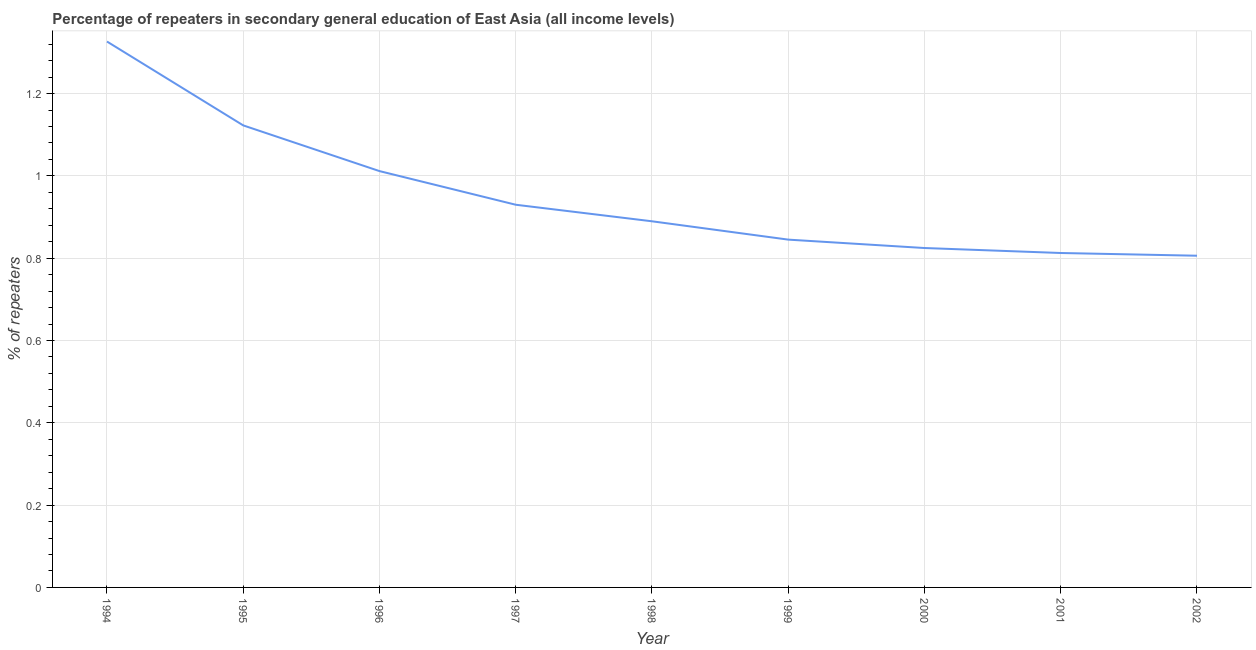What is the percentage of repeaters in 1998?
Provide a short and direct response. 0.89. Across all years, what is the maximum percentage of repeaters?
Provide a short and direct response. 1.33. Across all years, what is the minimum percentage of repeaters?
Make the answer very short. 0.81. In which year was the percentage of repeaters minimum?
Keep it short and to the point. 2002. What is the sum of the percentage of repeaters?
Provide a succinct answer. 8.57. What is the difference between the percentage of repeaters in 2001 and 2002?
Give a very brief answer. 0.01. What is the average percentage of repeaters per year?
Your answer should be compact. 0.95. What is the median percentage of repeaters?
Provide a succinct answer. 0.89. In how many years, is the percentage of repeaters greater than 0.12 %?
Provide a short and direct response. 9. Do a majority of the years between 1995 and 1997 (inclusive) have percentage of repeaters greater than 0.08 %?
Provide a succinct answer. Yes. What is the ratio of the percentage of repeaters in 1997 to that in 2000?
Your answer should be very brief. 1.13. Is the percentage of repeaters in 1994 less than that in 1999?
Provide a succinct answer. No. What is the difference between the highest and the second highest percentage of repeaters?
Keep it short and to the point. 0.2. What is the difference between the highest and the lowest percentage of repeaters?
Make the answer very short. 0.52. In how many years, is the percentage of repeaters greater than the average percentage of repeaters taken over all years?
Provide a short and direct response. 3. How many years are there in the graph?
Offer a very short reply. 9. Are the values on the major ticks of Y-axis written in scientific E-notation?
Your answer should be very brief. No. Does the graph contain any zero values?
Your answer should be very brief. No. Does the graph contain grids?
Keep it short and to the point. Yes. What is the title of the graph?
Provide a succinct answer. Percentage of repeaters in secondary general education of East Asia (all income levels). What is the label or title of the Y-axis?
Make the answer very short. % of repeaters. What is the % of repeaters in 1994?
Your answer should be very brief. 1.33. What is the % of repeaters of 1995?
Make the answer very short. 1.12. What is the % of repeaters of 1996?
Make the answer very short. 1.01. What is the % of repeaters of 1997?
Your answer should be compact. 0.93. What is the % of repeaters of 1998?
Give a very brief answer. 0.89. What is the % of repeaters in 1999?
Give a very brief answer. 0.85. What is the % of repeaters in 2000?
Ensure brevity in your answer.  0.82. What is the % of repeaters in 2001?
Make the answer very short. 0.81. What is the % of repeaters in 2002?
Offer a terse response. 0.81. What is the difference between the % of repeaters in 1994 and 1995?
Ensure brevity in your answer.  0.2. What is the difference between the % of repeaters in 1994 and 1996?
Offer a very short reply. 0.31. What is the difference between the % of repeaters in 1994 and 1997?
Offer a terse response. 0.4. What is the difference between the % of repeaters in 1994 and 1998?
Ensure brevity in your answer.  0.44. What is the difference between the % of repeaters in 1994 and 1999?
Ensure brevity in your answer.  0.48. What is the difference between the % of repeaters in 1994 and 2000?
Offer a terse response. 0.5. What is the difference between the % of repeaters in 1994 and 2001?
Offer a terse response. 0.51. What is the difference between the % of repeaters in 1994 and 2002?
Your answer should be very brief. 0.52. What is the difference between the % of repeaters in 1995 and 1996?
Your answer should be very brief. 0.11. What is the difference between the % of repeaters in 1995 and 1997?
Your response must be concise. 0.19. What is the difference between the % of repeaters in 1995 and 1998?
Your response must be concise. 0.23. What is the difference between the % of repeaters in 1995 and 1999?
Ensure brevity in your answer.  0.28. What is the difference between the % of repeaters in 1995 and 2000?
Your answer should be compact. 0.3. What is the difference between the % of repeaters in 1995 and 2001?
Your response must be concise. 0.31. What is the difference between the % of repeaters in 1995 and 2002?
Keep it short and to the point. 0.32. What is the difference between the % of repeaters in 1996 and 1997?
Provide a succinct answer. 0.08. What is the difference between the % of repeaters in 1996 and 1998?
Give a very brief answer. 0.12. What is the difference between the % of repeaters in 1996 and 1999?
Provide a short and direct response. 0.17. What is the difference between the % of repeaters in 1996 and 2000?
Offer a very short reply. 0.19. What is the difference between the % of repeaters in 1996 and 2001?
Offer a terse response. 0.2. What is the difference between the % of repeaters in 1996 and 2002?
Make the answer very short. 0.21. What is the difference between the % of repeaters in 1997 and 1998?
Make the answer very short. 0.04. What is the difference between the % of repeaters in 1997 and 1999?
Make the answer very short. 0.08. What is the difference between the % of repeaters in 1997 and 2000?
Keep it short and to the point. 0.11. What is the difference between the % of repeaters in 1997 and 2001?
Make the answer very short. 0.12. What is the difference between the % of repeaters in 1997 and 2002?
Your answer should be very brief. 0.12. What is the difference between the % of repeaters in 1998 and 1999?
Ensure brevity in your answer.  0.04. What is the difference between the % of repeaters in 1998 and 2000?
Provide a succinct answer. 0.06. What is the difference between the % of repeaters in 1998 and 2001?
Provide a succinct answer. 0.08. What is the difference between the % of repeaters in 1998 and 2002?
Give a very brief answer. 0.08. What is the difference between the % of repeaters in 1999 and 2000?
Your answer should be very brief. 0.02. What is the difference between the % of repeaters in 1999 and 2001?
Keep it short and to the point. 0.03. What is the difference between the % of repeaters in 1999 and 2002?
Keep it short and to the point. 0.04. What is the difference between the % of repeaters in 2000 and 2001?
Your answer should be very brief. 0.01. What is the difference between the % of repeaters in 2000 and 2002?
Offer a terse response. 0.02. What is the difference between the % of repeaters in 2001 and 2002?
Offer a terse response. 0.01. What is the ratio of the % of repeaters in 1994 to that in 1995?
Offer a very short reply. 1.18. What is the ratio of the % of repeaters in 1994 to that in 1996?
Your response must be concise. 1.31. What is the ratio of the % of repeaters in 1994 to that in 1997?
Your response must be concise. 1.43. What is the ratio of the % of repeaters in 1994 to that in 1998?
Keep it short and to the point. 1.49. What is the ratio of the % of repeaters in 1994 to that in 1999?
Keep it short and to the point. 1.57. What is the ratio of the % of repeaters in 1994 to that in 2000?
Your answer should be compact. 1.61. What is the ratio of the % of repeaters in 1994 to that in 2001?
Your answer should be very brief. 1.63. What is the ratio of the % of repeaters in 1994 to that in 2002?
Offer a very short reply. 1.65. What is the ratio of the % of repeaters in 1995 to that in 1996?
Keep it short and to the point. 1.11. What is the ratio of the % of repeaters in 1995 to that in 1997?
Your answer should be very brief. 1.21. What is the ratio of the % of repeaters in 1995 to that in 1998?
Your answer should be very brief. 1.26. What is the ratio of the % of repeaters in 1995 to that in 1999?
Ensure brevity in your answer.  1.33. What is the ratio of the % of repeaters in 1995 to that in 2000?
Your response must be concise. 1.36. What is the ratio of the % of repeaters in 1995 to that in 2001?
Your answer should be compact. 1.38. What is the ratio of the % of repeaters in 1995 to that in 2002?
Ensure brevity in your answer.  1.39. What is the ratio of the % of repeaters in 1996 to that in 1997?
Provide a short and direct response. 1.09. What is the ratio of the % of repeaters in 1996 to that in 1998?
Your answer should be compact. 1.14. What is the ratio of the % of repeaters in 1996 to that in 1999?
Offer a very short reply. 1.2. What is the ratio of the % of repeaters in 1996 to that in 2000?
Provide a short and direct response. 1.23. What is the ratio of the % of repeaters in 1996 to that in 2001?
Your answer should be very brief. 1.25. What is the ratio of the % of repeaters in 1996 to that in 2002?
Offer a very short reply. 1.25. What is the ratio of the % of repeaters in 1997 to that in 1998?
Your response must be concise. 1.04. What is the ratio of the % of repeaters in 1997 to that in 1999?
Provide a succinct answer. 1.1. What is the ratio of the % of repeaters in 1997 to that in 2000?
Ensure brevity in your answer.  1.13. What is the ratio of the % of repeaters in 1997 to that in 2001?
Ensure brevity in your answer.  1.14. What is the ratio of the % of repeaters in 1997 to that in 2002?
Keep it short and to the point. 1.15. What is the ratio of the % of repeaters in 1998 to that in 1999?
Offer a very short reply. 1.05. What is the ratio of the % of repeaters in 1998 to that in 2000?
Give a very brief answer. 1.08. What is the ratio of the % of repeaters in 1998 to that in 2001?
Provide a succinct answer. 1.09. What is the ratio of the % of repeaters in 1998 to that in 2002?
Keep it short and to the point. 1.1. What is the ratio of the % of repeaters in 1999 to that in 2000?
Offer a very short reply. 1.02. What is the ratio of the % of repeaters in 1999 to that in 2002?
Provide a short and direct response. 1.05. What is the ratio of the % of repeaters in 2000 to that in 2002?
Keep it short and to the point. 1.02. 